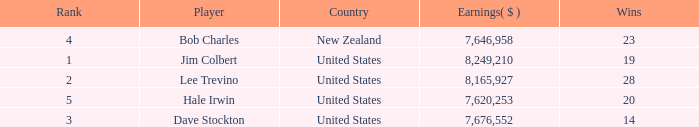How many players named bob charles with earnings over $7,646,958? 0.0. 